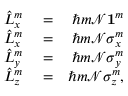<formula> <loc_0><loc_0><loc_500><loc_500>\begin{array} { r l r } { \hat { L } _ { x } ^ { m } } & = } & { \hbar { m } { \mathcal { N } } { 1 } ^ { m } } \\ { \hat { L } _ { x } ^ { m } } & = } & { \hbar { m } { \mathcal { N } } \sigma _ { x } ^ { m } } \\ { \hat { L } _ { y } ^ { m } } & = } & { \hbar { m } { \mathcal { N } } \sigma _ { y } ^ { m } } \\ { \hat { L } _ { z } ^ { m } } & = } & { \hbar { m } { \mathcal { N } } \sigma _ { z } ^ { m } , } \end{array}</formula> 